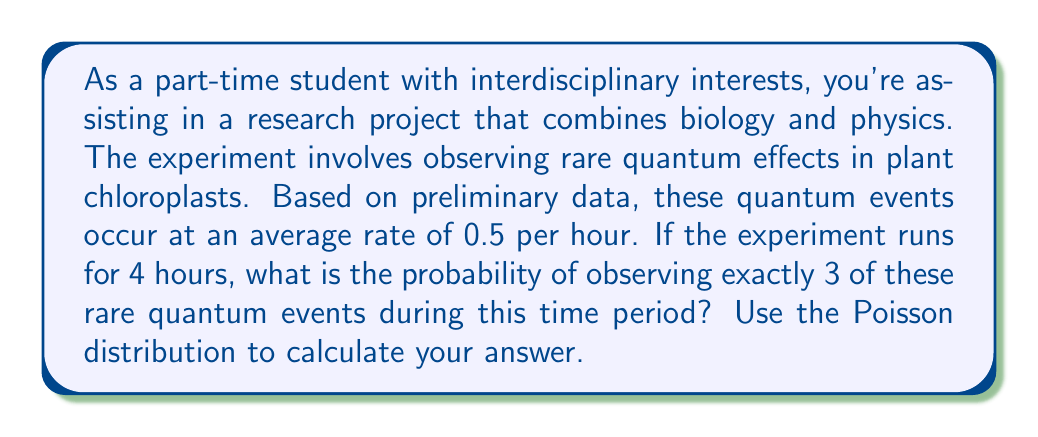Solve this math problem. To solve this problem, we'll use the Poisson distribution, which is ideal for modeling rare events occurring in a fixed interval of time or space. The Poisson probability mass function is given by:

$$P(X = k) = \frac{e^{-\lambda} \lambda^k}{k!}$$

Where:
- $\lambda$ is the average rate of events in the given interval
- $k$ is the number of events we're interested in
- $e$ is Euler's number (approximately 2.71828)

Given:
- Average rate: 0.5 events per hour
- Time period: 4 hours
- Number of events we're interested in: 3

Step 1: Calculate $\lambda$ for the entire 4-hour period
$\lambda = 0.5 \text{ events/hour} \times 4 \text{ hours} = 2$

Step 2: Apply the Poisson formula
$$P(X = 3) = \frac{e^{-2} 2^3}{3!}$$

Step 3: Calculate each part
- $e^{-2} \approx 0.1353$
- $2^3 = 8$
- $3! = 3 \times 2 \times 1 = 6$

Step 4: Put it all together
$$P(X = 3) = \frac{0.1353 \times 8}{6} \approx 0.1804$$

Therefore, the probability of observing exactly 3 rare quantum events during the 4-hour experiment is approximately 0.1804 or 18.04%.
Answer: $P(X = 3) \approx 0.1804$ or 18.04% 